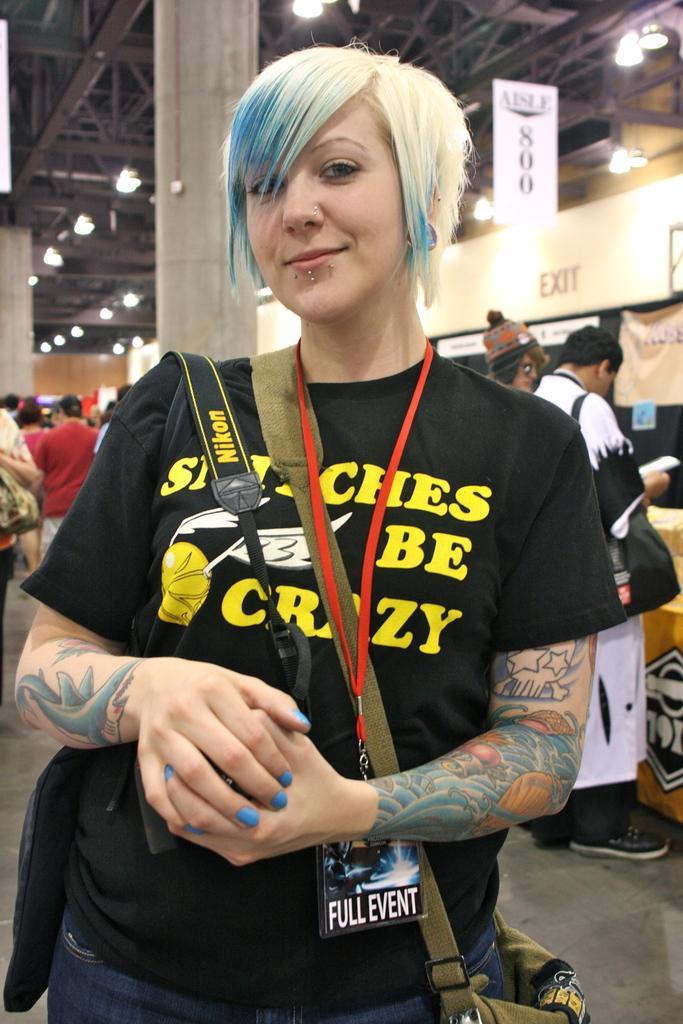Please provide a concise description of this image. In this image we can see a woman wearing a bag standing on the floor. On the backside we can see a roof with ceiling lights, pillar and people standing. 